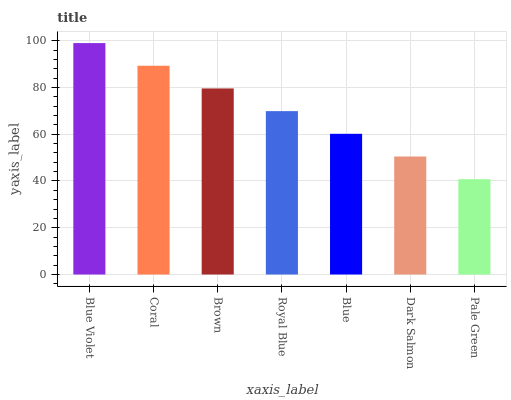Is Pale Green the minimum?
Answer yes or no. Yes. Is Blue Violet the maximum?
Answer yes or no. Yes. Is Coral the minimum?
Answer yes or no. No. Is Coral the maximum?
Answer yes or no. No. Is Blue Violet greater than Coral?
Answer yes or no. Yes. Is Coral less than Blue Violet?
Answer yes or no. Yes. Is Coral greater than Blue Violet?
Answer yes or no. No. Is Blue Violet less than Coral?
Answer yes or no. No. Is Royal Blue the high median?
Answer yes or no. Yes. Is Royal Blue the low median?
Answer yes or no. Yes. Is Blue the high median?
Answer yes or no. No. Is Blue Violet the low median?
Answer yes or no. No. 